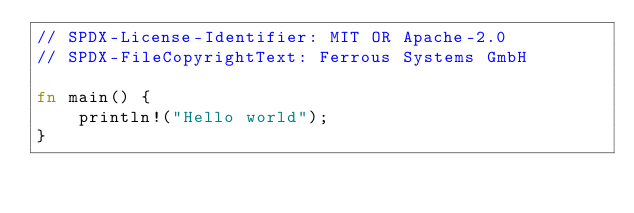<code> <loc_0><loc_0><loc_500><loc_500><_Rust_>// SPDX-License-Identifier: MIT OR Apache-2.0
// SPDX-FileCopyrightText: Ferrous Systems GmbH

fn main() {
    println!("Hello world");
}
</code> 